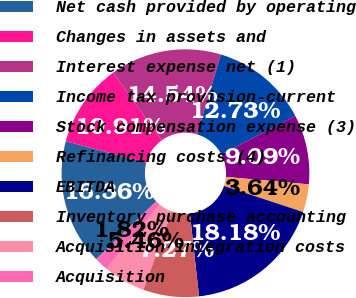<chart> <loc_0><loc_0><loc_500><loc_500><pie_chart><fcel>Net cash provided by operating<fcel>Changes in assets and<fcel>Interest expense net (1)<fcel>Income tax provision-current<fcel>Stock compensation expense (3)<fcel>Refinancing costs (4)<fcel>EBITDA<fcel>Inventory purchase accounting<fcel>Acquisition integration costs<fcel>Acquisition<nl><fcel>16.36%<fcel>10.91%<fcel>14.54%<fcel>12.73%<fcel>9.09%<fcel>3.64%<fcel>18.18%<fcel>7.27%<fcel>5.46%<fcel>1.82%<nl></chart> 